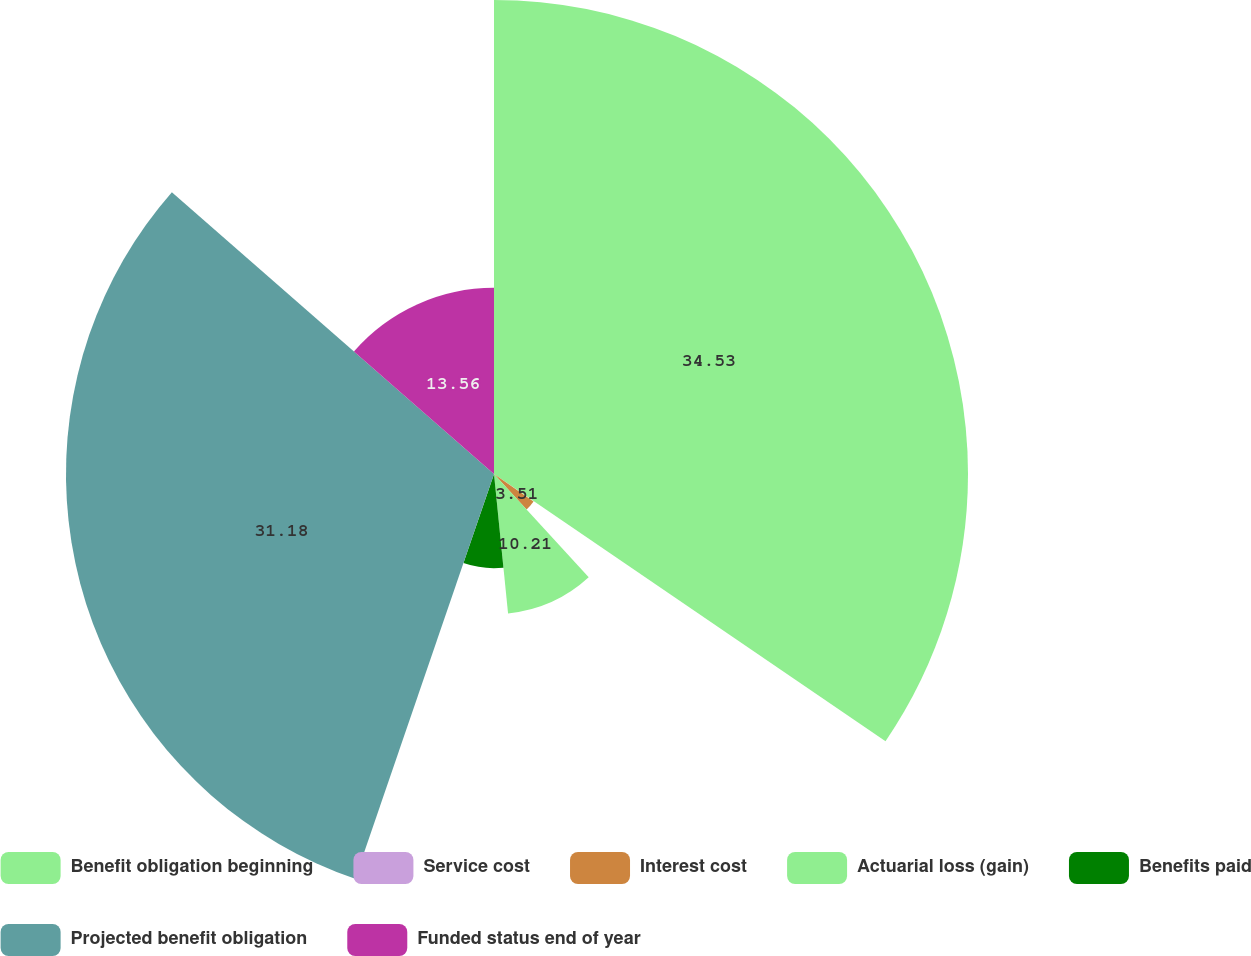<chart> <loc_0><loc_0><loc_500><loc_500><pie_chart><fcel>Benefit obligation beginning<fcel>Service cost<fcel>Interest cost<fcel>Actuarial loss (gain)<fcel>Benefits paid<fcel>Projected benefit obligation<fcel>Funded status end of year<nl><fcel>34.53%<fcel>0.15%<fcel>3.51%<fcel>10.21%<fcel>6.86%<fcel>31.18%<fcel>13.56%<nl></chart> 